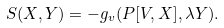<formula> <loc_0><loc_0><loc_500><loc_500>S ( X , Y ) = - g _ { v } ( P [ V , X ] , \lambda Y ) .</formula> 